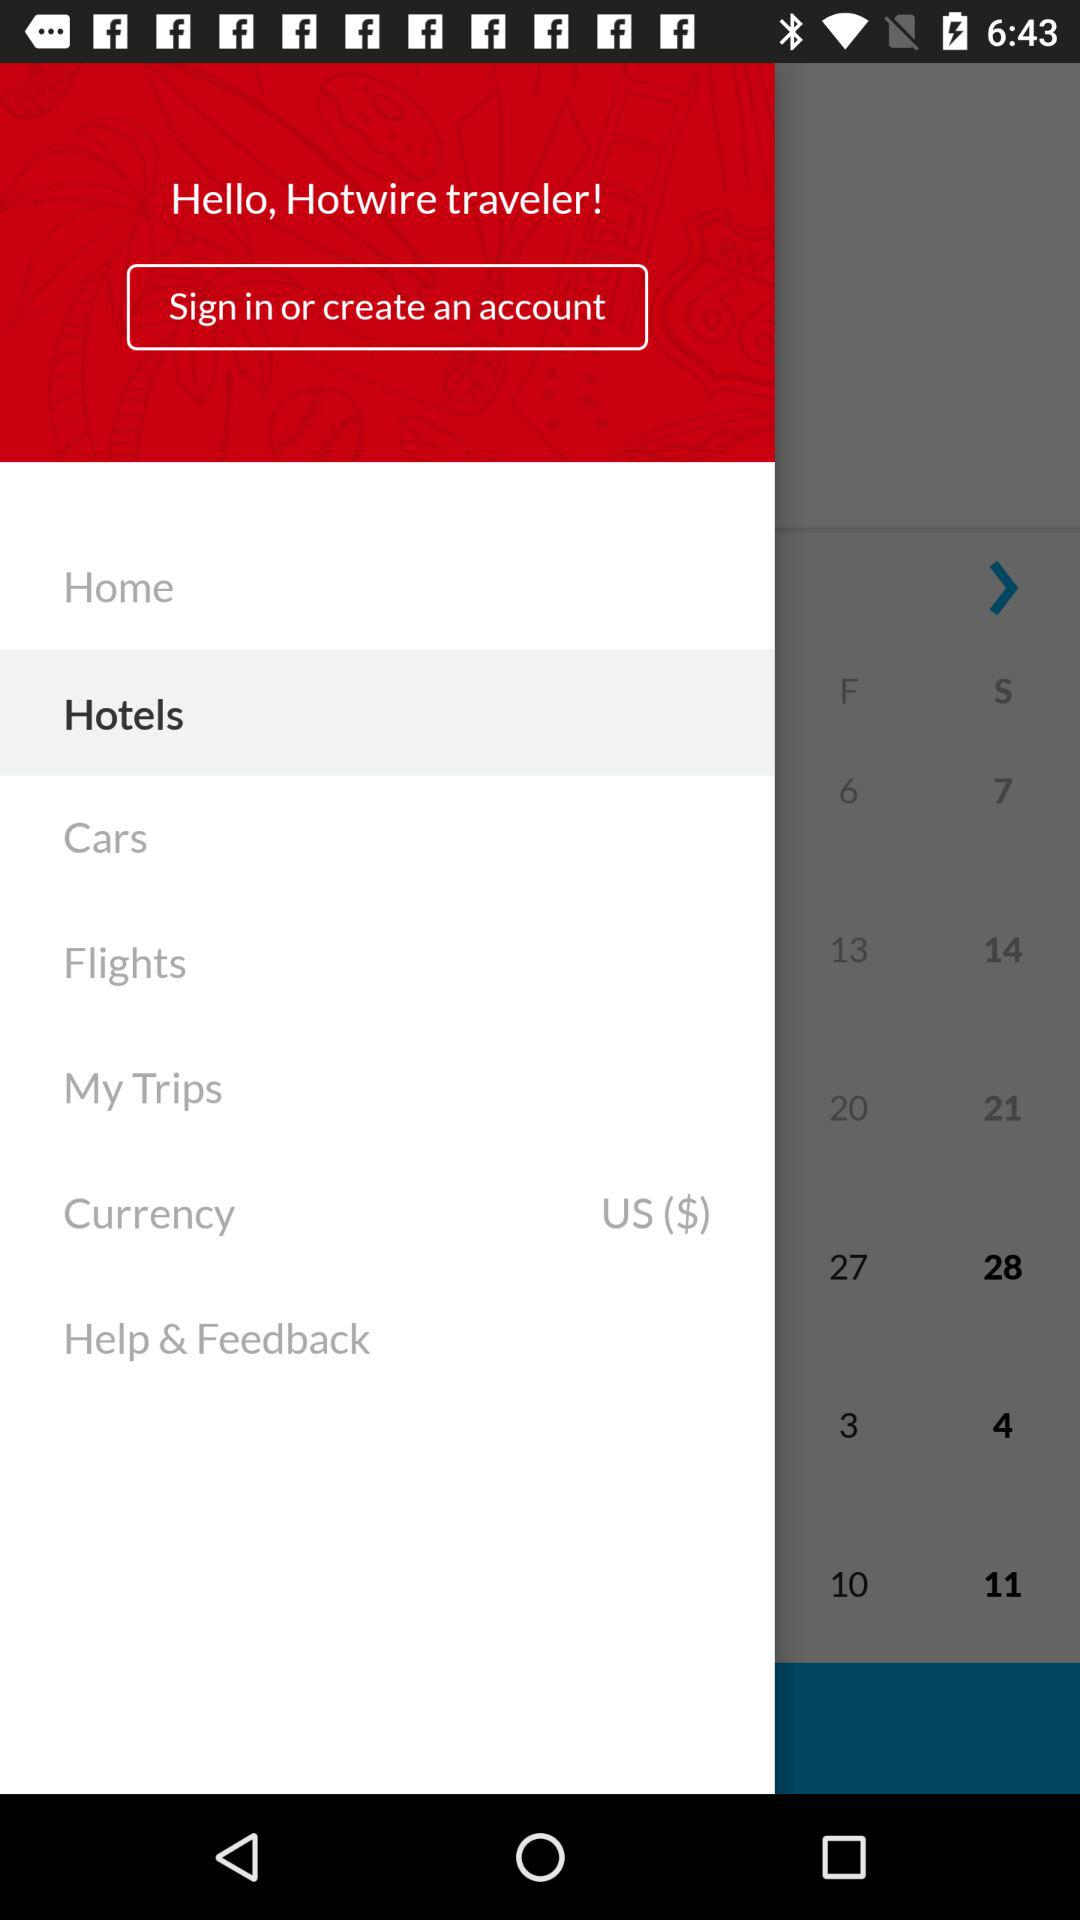What is the selected currency? The selected currency is USD ($). 